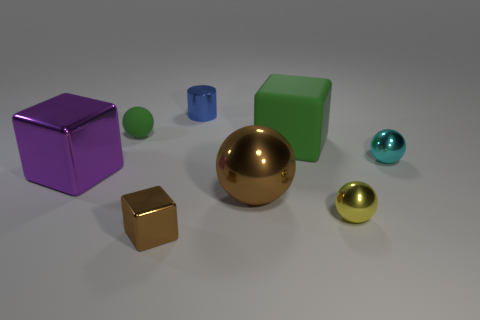There is a big block that is in front of the tiny cyan object; are there any green cubes left of it?
Ensure brevity in your answer.  No. How many blue objects are either cylinders or matte cylinders?
Offer a terse response. 1. The big shiny ball is what color?
Keep it short and to the point. Brown. There is a cyan sphere that is made of the same material as the big brown thing; what size is it?
Give a very brief answer. Small. What number of tiny green things are the same shape as the tiny yellow shiny object?
Provide a short and direct response. 1. Are there any other things that are the same size as the blue metallic thing?
Keep it short and to the point. Yes. What is the size of the rubber thing on the left side of the green thing right of the small brown metallic object?
Provide a short and direct response. Small. What material is the ball that is the same size as the rubber block?
Your answer should be compact. Metal. Is there a big purple block made of the same material as the small green sphere?
Ensure brevity in your answer.  No. What color is the tiny ball that is in front of the large metallic thing that is to the right of the green rubber object to the left of the large rubber block?
Offer a terse response. Yellow. 